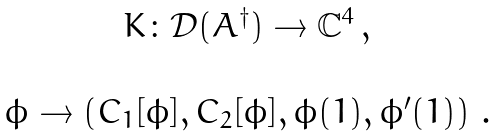<formula> <loc_0><loc_0><loc_500><loc_500>\begin{array} { c } K \colon \mathcal { D } ( A ^ { \dagger } ) \rightarrow \mathbb { C } ^ { 4 } \, , \\ \\ \phi \rightarrow \left ( C _ { 1 } [ \phi ] , C _ { 2 } [ \phi ] , \phi ( 1 ) , \phi ^ { \prime } ( 1 ) \right ) \, . \end{array}</formula> 